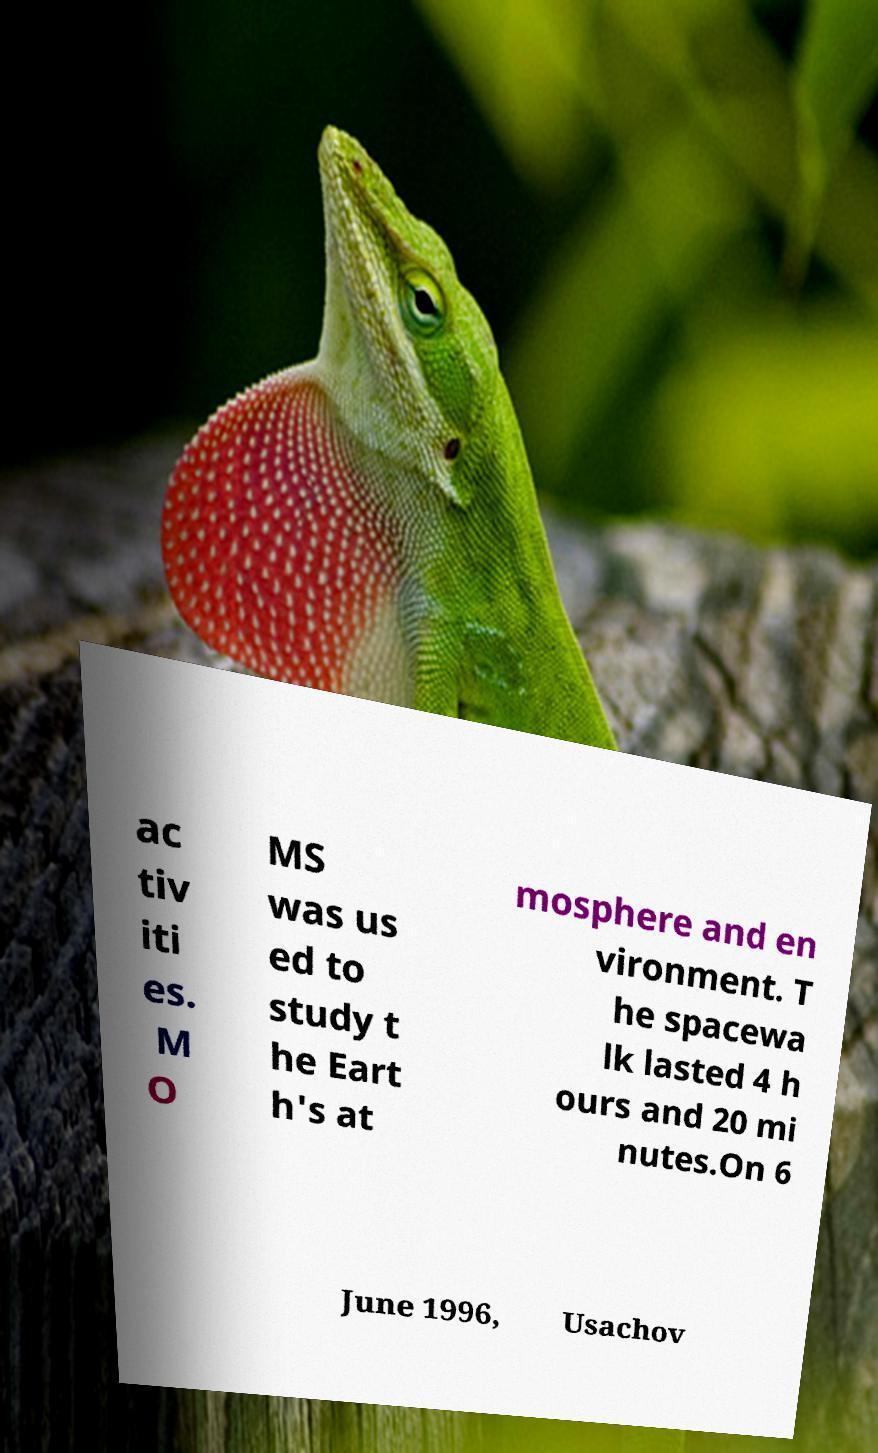Can you accurately transcribe the text from the provided image for me? ac tiv iti es. M O MS was us ed to study t he Eart h's at mosphere and en vironment. T he spacewa lk lasted 4 h ours and 20 mi nutes.On 6 June 1996, Usachov 